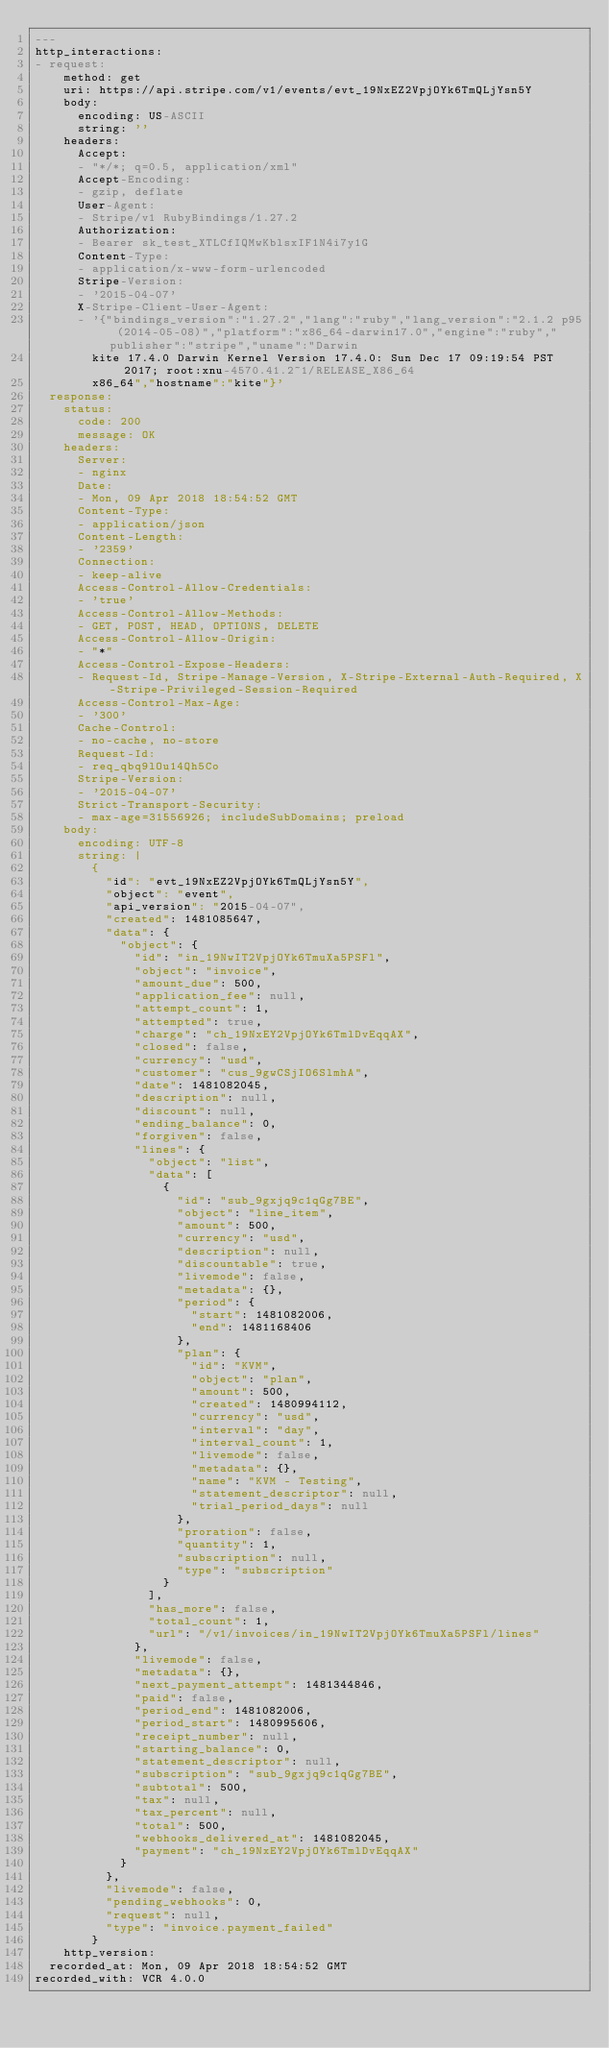Convert code to text. <code><loc_0><loc_0><loc_500><loc_500><_YAML_>---
http_interactions:
- request:
    method: get
    uri: https://api.stripe.com/v1/events/evt_19NxEZ2VpjOYk6TmQLjYsn5Y
    body:
      encoding: US-ASCII
      string: ''
    headers:
      Accept:
      - "*/*; q=0.5, application/xml"
      Accept-Encoding:
      - gzip, deflate
      User-Agent:
      - Stripe/v1 RubyBindings/1.27.2
      Authorization:
      - Bearer sk_test_XTLCfIQMwKblsxIF1N4i7y1G
      Content-Type:
      - application/x-www-form-urlencoded
      Stripe-Version:
      - '2015-04-07'
      X-Stripe-Client-User-Agent:
      - '{"bindings_version":"1.27.2","lang":"ruby","lang_version":"2.1.2 p95 (2014-05-08)","platform":"x86_64-darwin17.0","engine":"ruby","publisher":"stripe","uname":"Darwin
        kite 17.4.0 Darwin Kernel Version 17.4.0: Sun Dec 17 09:19:54 PST 2017; root:xnu-4570.41.2~1/RELEASE_X86_64
        x86_64","hostname":"kite"}'
  response:
    status:
      code: 200
      message: OK
    headers:
      Server:
      - nginx
      Date:
      - Mon, 09 Apr 2018 18:54:52 GMT
      Content-Type:
      - application/json
      Content-Length:
      - '2359'
      Connection:
      - keep-alive
      Access-Control-Allow-Credentials:
      - 'true'
      Access-Control-Allow-Methods:
      - GET, POST, HEAD, OPTIONS, DELETE
      Access-Control-Allow-Origin:
      - "*"
      Access-Control-Expose-Headers:
      - Request-Id, Stripe-Manage-Version, X-Stripe-External-Auth-Required, X-Stripe-Privileged-Session-Required
      Access-Control-Max-Age:
      - '300'
      Cache-Control:
      - no-cache, no-store
      Request-Id:
      - req_qbq9lOu14Qh5Co
      Stripe-Version:
      - '2015-04-07'
      Strict-Transport-Security:
      - max-age=31556926; includeSubDomains; preload
    body:
      encoding: UTF-8
      string: |
        {
          "id": "evt_19NxEZ2VpjOYk6TmQLjYsn5Y",
          "object": "event",
          "api_version": "2015-04-07",
          "created": 1481085647,
          "data": {
            "object": {
              "id": "in_19NwIT2VpjOYk6TmuXa5PSFl",
              "object": "invoice",
              "amount_due": 500,
              "application_fee": null,
              "attempt_count": 1,
              "attempted": true,
              "charge": "ch_19NxEY2VpjOYk6TmlDvEqqAX",
              "closed": false,
              "currency": "usd",
              "customer": "cus_9gwCSjIO6SlmhA",
              "date": 1481082045,
              "description": null,
              "discount": null,
              "ending_balance": 0,
              "forgiven": false,
              "lines": {
                "object": "list",
                "data": [
                  {
                    "id": "sub_9gxjq9c1qGg7BE",
                    "object": "line_item",
                    "amount": 500,
                    "currency": "usd",
                    "description": null,
                    "discountable": true,
                    "livemode": false,
                    "metadata": {},
                    "period": {
                      "start": 1481082006,
                      "end": 1481168406
                    },
                    "plan": {
                      "id": "KVM",
                      "object": "plan",
                      "amount": 500,
                      "created": 1480994112,
                      "currency": "usd",
                      "interval": "day",
                      "interval_count": 1,
                      "livemode": false,
                      "metadata": {},
                      "name": "KVM - Testing",
                      "statement_descriptor": null,
                      "trial_period_days": null
                    },
                    "proration": false,
                    "quantity": 1,
                    "subscription": null,
                    "type": "subscription"
                  }
                ],
                "has_more": false,
                "total_count": 1,
                "url": "/v1/invoices/in_19NwIT2VpjOYk6TmuXa5PSFl/lines"
              },
              "livemode": false,
              "metadata": {},
              "next_payment_attempt": 1481344846,
              "paid": false,
              "period_end": 1481082006,
              "period_start": 1480995606,
              "receipt_number": null,
              "starting_balance": 0,
              "statement_descriptor": null,
              "subscription": "sub_9gxjq9c1qGg7BE",
              "subtotal": 500,
              "tax": null,
              "tax_percent": null,
              "total": 500,
              "webhooks_delivered_at": 1481082045,
              "payment": "ch_19NxEY2VpjOYk6TmlDvEqqAX"
            }
          },
          "livemode": false,
          "pending_webhooks": 0,
          "request": null,
          "type": "invoice.payment_failed"
        }
    http_version: 
  recorded_at: Mon, 09 Apr 2018 18:54:52 GMT
recorded_with: VCR 4.0.0
</code> 